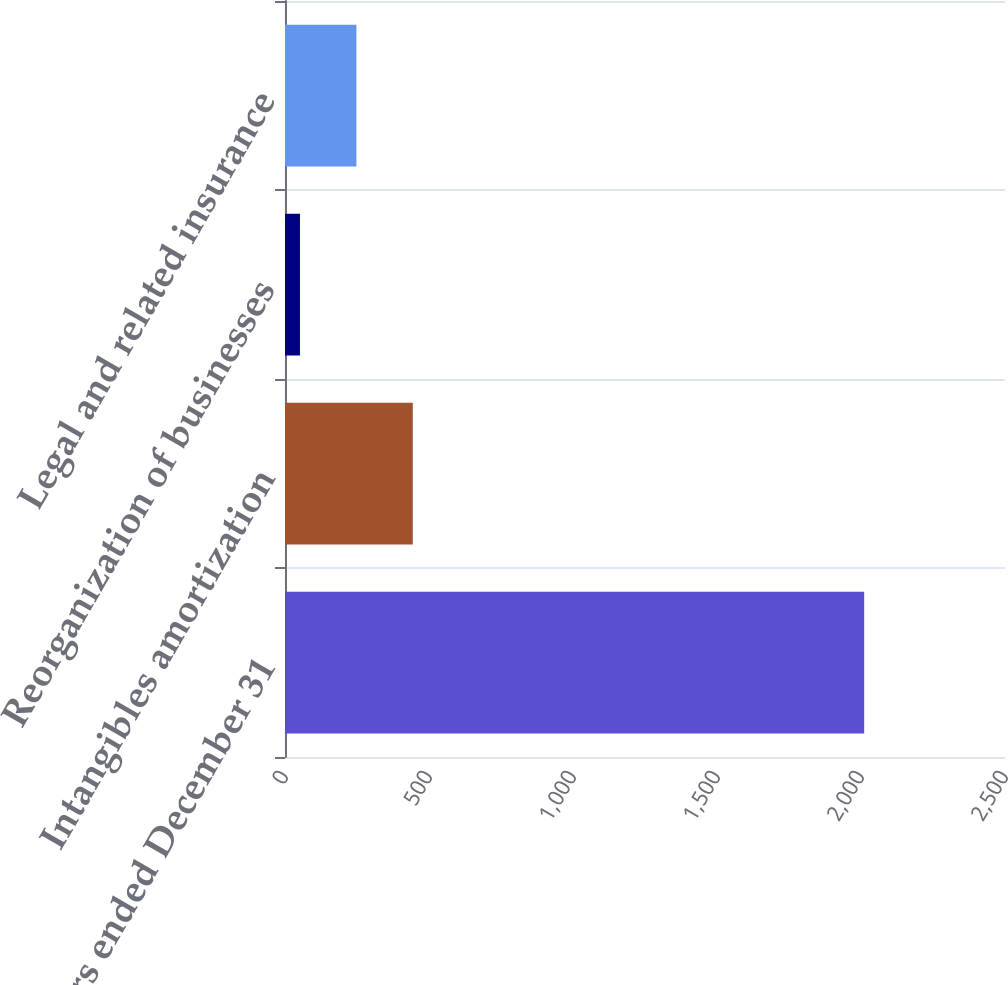<chart> <loc_0><loc_0><loc_500><loc_500><bar_chart><fcel>Years ended December 31<fcel>Intangibles amortization<fcel>Reorganization of businesses<fcel>Legal and related insurance<nl><fcel>2011<fcel>443.8<fcel>52<fcel>247.9<nl></chart> 